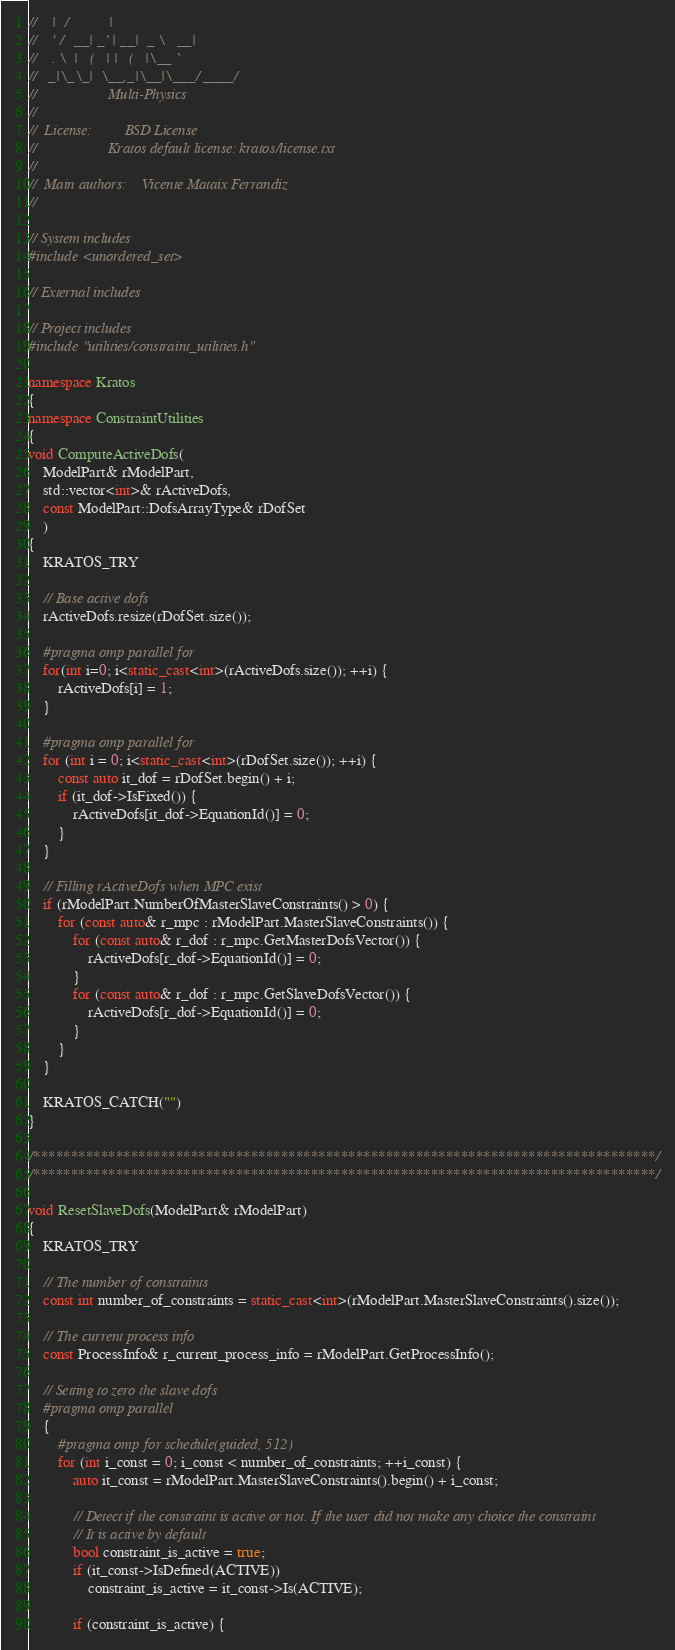Convert code to text. <code><loc_0><loc_0><loc_500><loc_500><_C++_>//    |  /           |
//    ' /   __| _` | __|  _ \   __|
//    . \  |   (   | |   (   |\__ `
//   _|\_\_|  \__,_|\__|\___/ ____/
//                   Multi-Physics
//
//  License:		 BSD License
//					 Kratos default license: kratos/license.txt
//
//  Main authors:    Vicente Mataix Ferrandiz
//

// System includes
#include <unordered_set>

// External includes

// Project includes
#include "utilities/constraint_utilities.h"

namespace Kratos
{
namespace ConstraintUtilities
{
void ComputeActiveDofs(
    ModelPart& rModelPart,
    std::vector<int>& rActiveDofs,
    const ModelPart::DofsArrayType& rDofSet
    )
{
    KRATOS_TRY

    // Base active dofs
    rActiveDofs.resize(rDofSet.size());

    #pragma omp parallel for
    for(int i=0; i<static_cast<int>(rActiveDofs.size()); ++i) {
        rActiveDofs[i] = 1;
    }

    #pragma omp parallel for
    for (int i = 0; i<static_cast<int>(rDofSet.size()); ++i) {
        const auto it_dof = rDofSet.begin() + i;
        if (it_dof->IsFixed()) {
            rActiveDofs[it_dof->EquationId()] = 0;
        }
    }

    // Filling rActiveDofs when MPC exist
    if (rModelPart.NumberOfMasterSlaveConstraints() > 0) {
        for (const auto& r_mpc : rModelPart.MasterSlaveConstraints()) {
            for (const auto& r_dof : r_mpc.GetMasterDofsVector()) {
                rActiveDofs[r_dof->EquationId()] = 0;
            }
            for (const auto& r_dof : r_mpc.GetSlaveDofsVector()) {
                rActiveDofs[r_dof->EquationId()] = 0;
            }
        }
    }

    KRATOS_CATCH("")
}

/***********************************************************************************/
/***********************************************************************************/

void ResetSlaveDofs(ModelPart& rModelPart)
{
    KRATOS_TRY

    // The number of constraints
    const int number_of_constraints = static_cast<int>(rModelPart.MasterSlaveConstraints().size());

    // The current process info
    const ProcessInfo& r_current_process_info = rModelPart.GetProcessInfo();

    // Setting to zero the slave dofs
    #pragma omp parallel
    {
        #pragma omp for schedule(guided, 512)
        for (int i_const = 0; i_const < number_of_constraints; ++i_const) {
            auto it_const = rModelPart.MasterSlaveConstraints().begin() + i_const;

            // Detect if the constraint is active or not. If the user did not make any choice the constraint
            // It is active by default
            bool constraint_is_active = true;
            if (it_const->IsDefined(ACTIVE))
                constraint_is_active = it_const->Is(ACTIVE);

            if (constraint_is_active) {</code> 